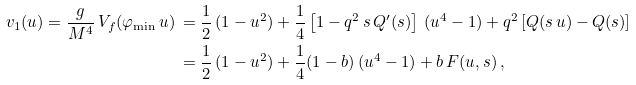Convert formula to latex. <formula><loc_0><loc_0><loc_500><loc_500>v _ { 1 } ( u ) = \frac { g } { M ^ { 4 } } \, V _ { f } ( \varphi _ { \min } \, u ) \, & = \frac { 1 } { 2 } \, ( 1 - u ^ { 2 } ) + \frac { 1 } { 4 } \left [ 1 - q ^ { 2 } \, s \, Q ^ { \prime } ( s ) \right ] \, ( u ^ { 4 } - 1 ) + q ^ { 2 } \left [ Q ( s \, u ) - Q ( s ) \right ] \\ & = \frac { 1 } { 2 } \, ( 1 - u ^ { 2 } ) + \frac { 1 } { 4 } ( 1 - b ) \, ( u ^ { 4 } - 1 ) + b \, F ( u , s ) \, ,</formula> 